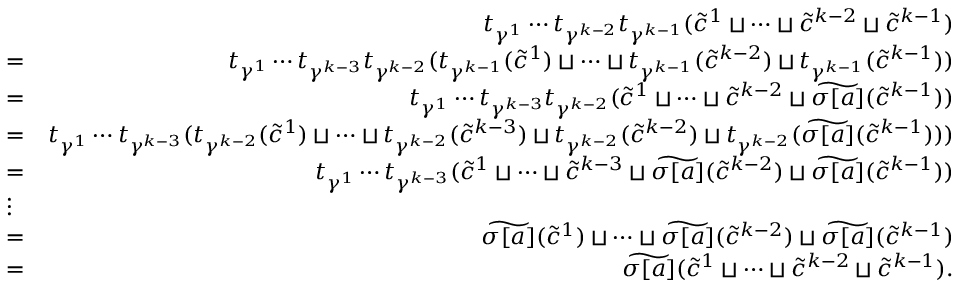Convert formula to latex. <formula><loc_0><loc_0><loc_500><loc_500>\begin{array} { r l r } & { t _ { \gamma ^ { 1 } } \cdots t _ { \gamma ^ { k - 2 } } t _ { \gamma ^ { k - 1 } } ( \widetilde { c } ^ { 1 } \sqcup \cdots \sqcup \widetilde { c } ^ { k - 2 } \sqcup \widetilde { c } ^ { k - 1 } ) } \\ & { = } & { t _ { \gamma ^ { 1 } } \cdots t _ { \gamma ^ { k - 3 } } t _ { \gamma ^ { k - 2 } } ( t _ { \gamma ^ { k - 1 } } ( \widetilde { c } ^ { 1 } ) \sqcup \cdots \sqcup t _ { \gamma ^ { k - 1 } } ( \widetilde { c } ^ { k - 2 } ) \sqcup t _ { \gamma ^ { k - 1 } } ( \widetilde { c } ^ { k - 1 } ) ) } \\ & { = } & { t _ { \gamma ^ { 1 } } \cdots t _ { \gamma ^ { k - 3 } } t _ { \gamma ^ { k - 2 } } ( \widetilde { c } ^ { 1 } \sqcup \cdots \sqcup \widetilde { c } ^ { k - 2 } \sqcup \widetilde { \sigma [ a ] } ( \widetilde { c } ^ { k - 1 } ) ) } \\ & { = } & { t _ { \gamma ^ { 1 } } \cdots t _ { \gamma ^ { k - 3 } } ( t _ { \gamma ^ { k - 2 } } ( \widetilde { c } ^ { 1 } ) \sqcup \cdots \sqcup t _ { \gamma ^ { k - 2 } } ( \widetilde { c } ^ { k - 3 } ) \sqcup t _ { \gamma ^ { k - 2 } } ( \widetilde { c } ^ { k - 2 } ) \sqcup t _ { \gamma ^ { k - 2 } } ( \widetilde { \sigma [ a ] } ( \widetilde { c } ^ { k - 1 } ) ) ) } \\ & { = } & { t _ { \gamma ^ { 1 } } \cdots t _ { \gamma ^ { k - 3 } } ( \widetilde { c } ^ { 1 } \sqcup \cdots \sqcup \widetilde { c } ^ { k - 3 } \sqcup \widetilde { \sigma [ a ] } ( \widetilde { c } ^ { k - 2 } ) \sqcup \widetilde { \sigma [ a ] } ( \widetilde { c } ^ { k - 1 } ) ) } \\ & { \vdots } & \\ & { = } & { \widetilde { \sigma [ a ] } ( \widetilde { c } ^ { 1 } ) \sqcup \cdots \sqcup \widetilde { \sigma [ a ] } ( \widetilde { c } ^ { k - 2 } ) \sqcup \widetilde { \sigma [ a ] } ( \widetilde { c } ^ { k - 1 } ) } \\ & { = } & { \widetilde { \sigma [ a ] } ( \widetilde { c } ^ { 1 } \sqcup \cdots \sqcup \widetilde { c } ^ { k - 2 } \sqcup \widetilde { c } ^ { k - 1 } ) . } \end{array}</formula> 